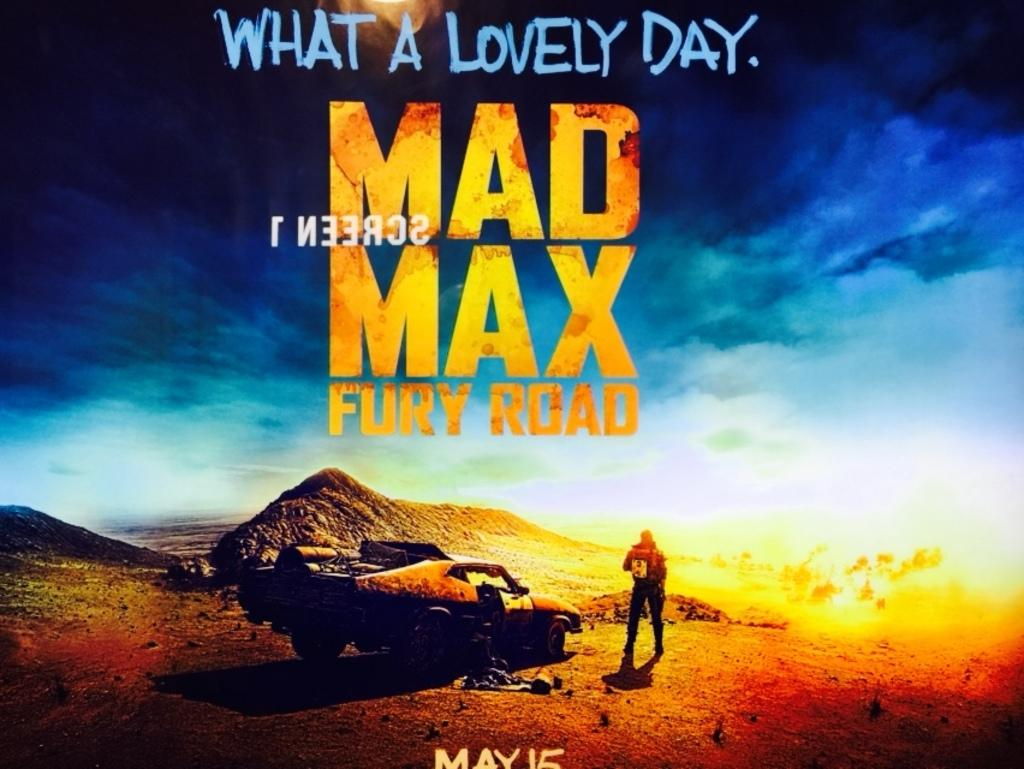<image>
Share a concise interpretation of the image provided. A poster for Mad Max Fury Road to be seen on May 15. 